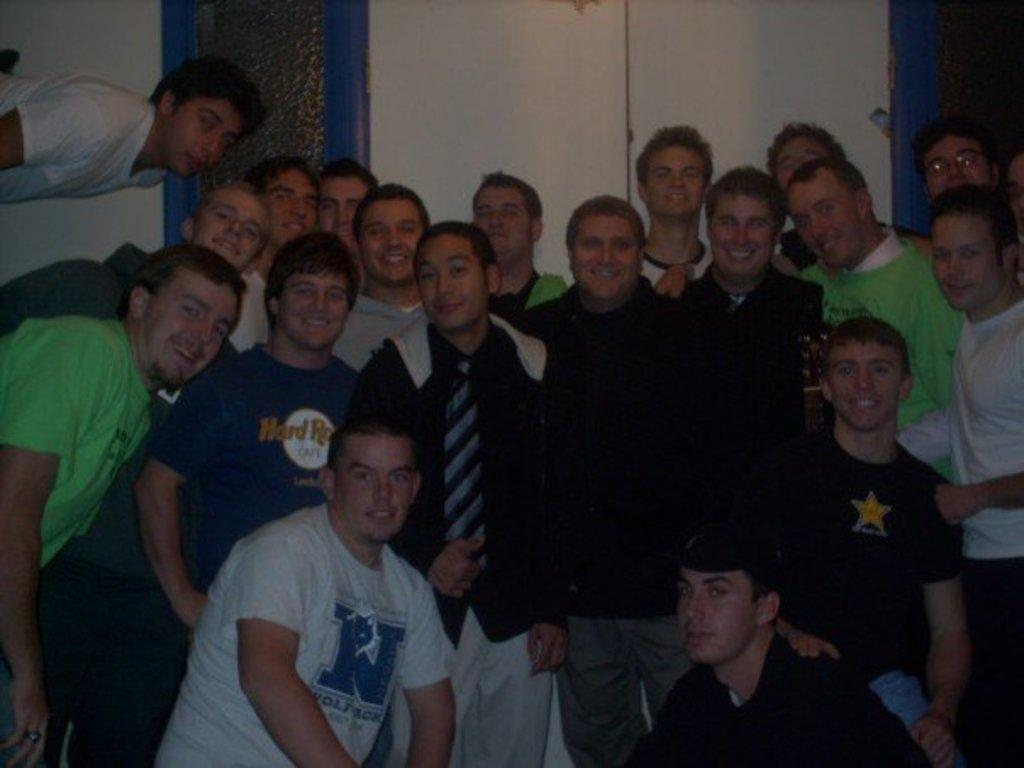How many people are in the image? There is a group of persons in the image. Where are the persons located in the image? The group of persons is standing in the middle of the image. What can be seen in the background of the image? There is a wall in the background of the image. What type of advice is being given by the door in the image? There is no door present in the image, so it cannot provide any advice. 